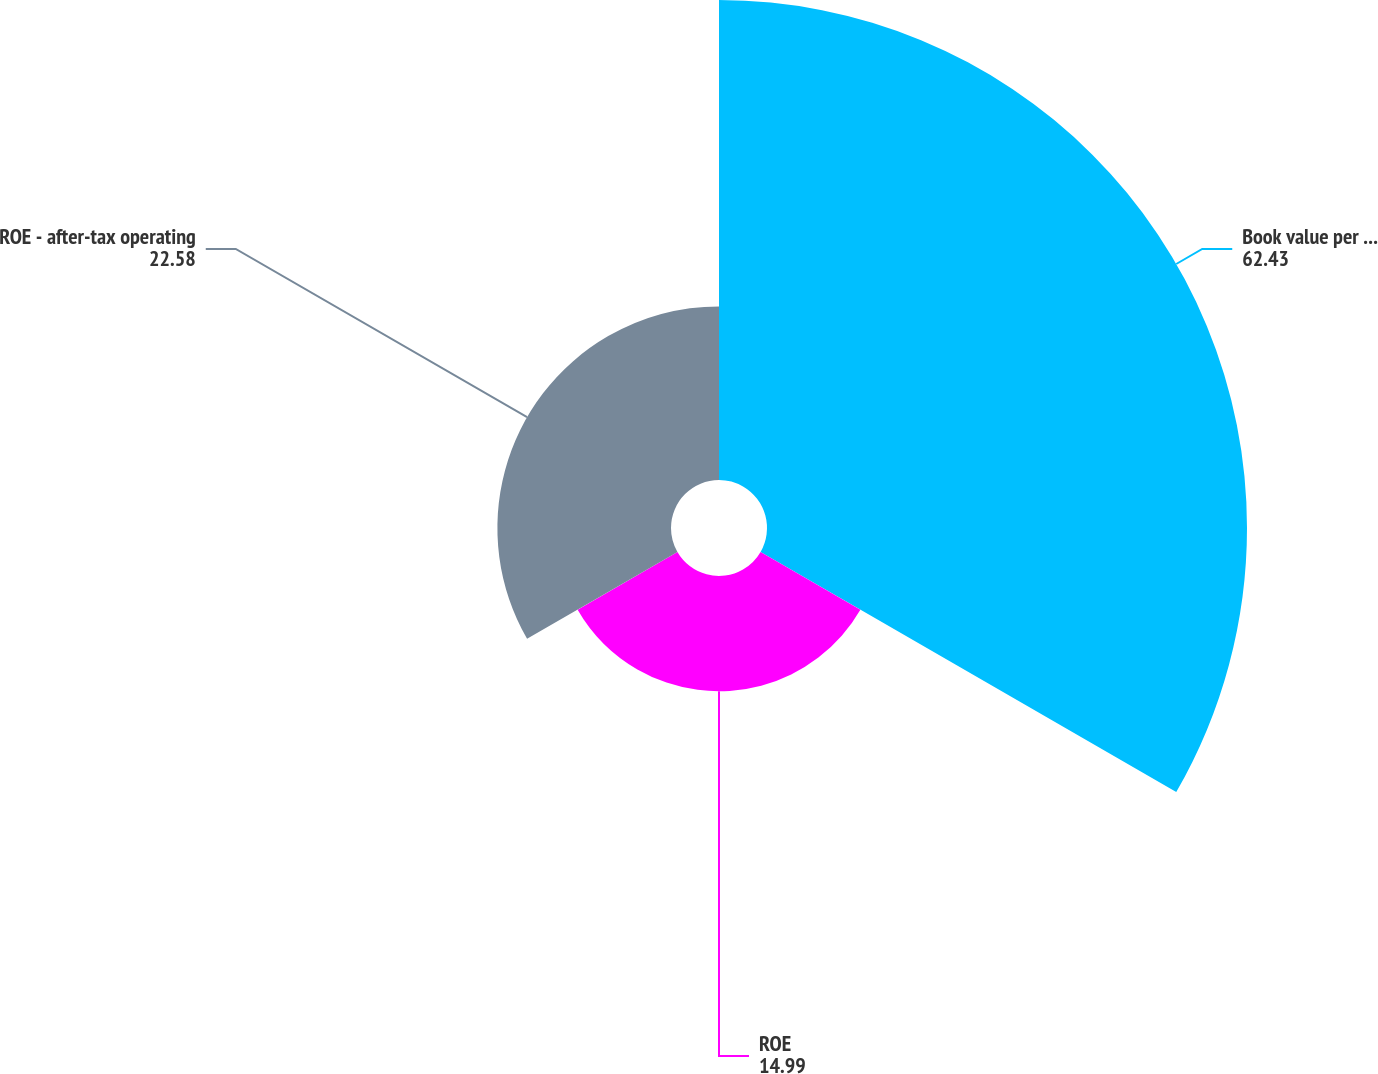Convert chart. <chart><loc_0><loc_0><loc_500><loc_500><pie_chart><fcel>Book value per common share<fcel>ROE<fcel>ROE - after-tax operating<nl><fcel>62.43%<fcel>14.99%<fcel>22.58%<nl></chart> 